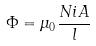<formula> <loc_0><loc_0><loc_500><loc_500>\Phi = \mu _ { 0 } \frac { N i A } { l }</formula> 